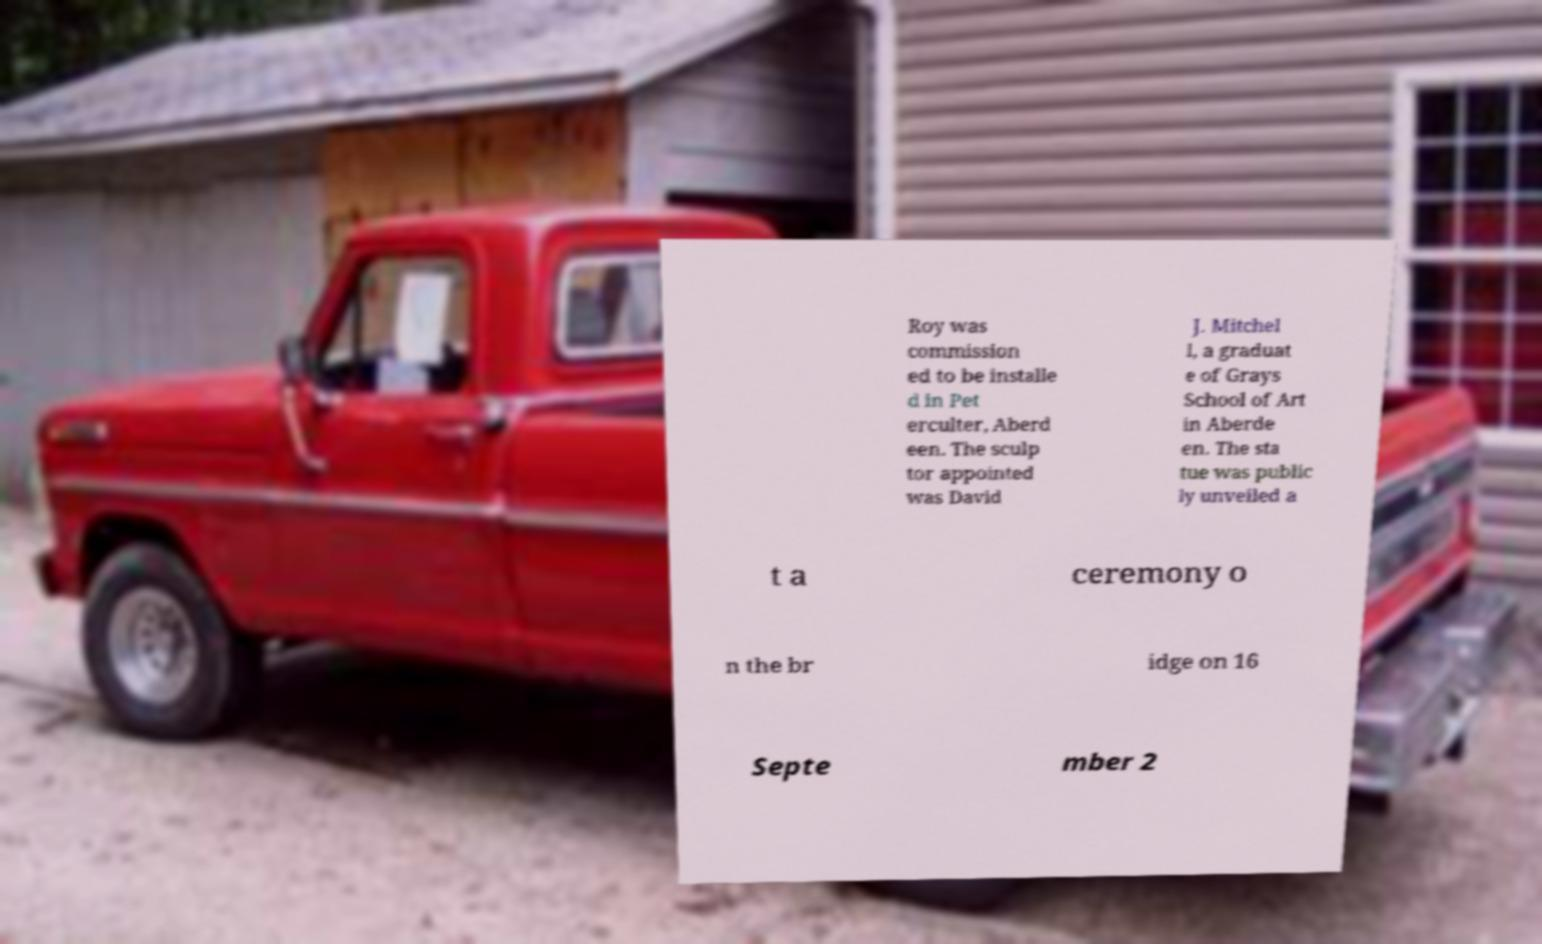Can you read and provide the text displayed in the image?This photo seems to have some interesting text. Can you extract and type it out for me? Roy was commission ed to be installe d in Pet erculter, Aberd een. The sculp tor appointed was David J. Mitchel l, a graduat e of Grays School of Art in Aberde en. The sta tue was public ly unveiled a t a ceremony o n the br idge on 16 Septe mber 2 